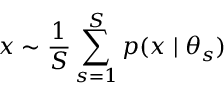<formula> <loc_0><loc_0><loc_500><loc_500>x \sim \frac { 1 } { S } \sum _ { s = 1 } ^ { S } p ( x | \theta _ { s } )</formula> 